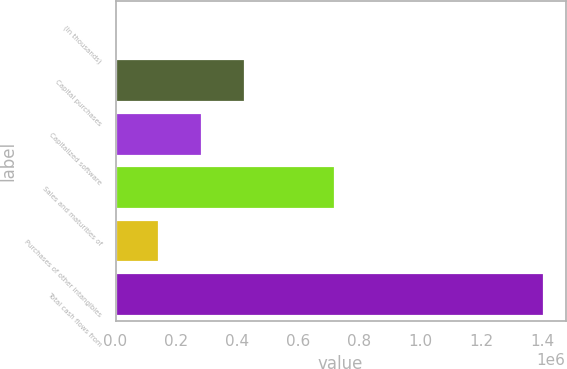Convert chart to OTSL. <chart><loc_0><loc_0><loc_500><loc_500><bar_chart><fcel>(In thousands)<fcel>Capital purchases<fcel>Capitalized software<fcel>Sales and maturities of<fcel>Purchases of other intangibles<fcel>Total cash flows from<nl><fcel>2015<fcel>423193<fcel>282801<fcel>720406<fcel>142408<fcel>1.40594e+06<nl></chart> 